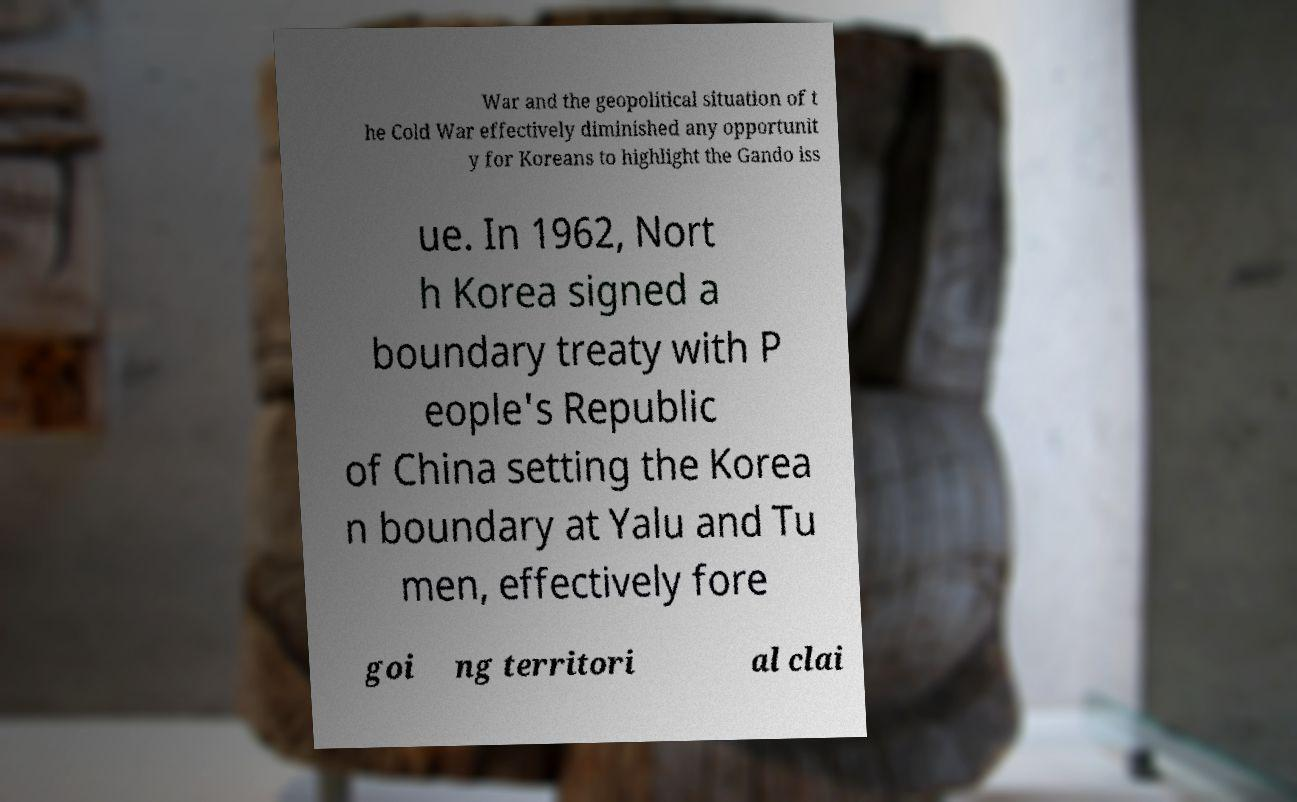There's text embedded in this image that I need extracted. Can you transcribe it verbatim? War and the geopolitical situation of t he Cold War effectively diminished any opportunit y for Koreans to highlight the Gando iss ue. In 1962, Nort h Korea signed a boundary treaty with P eople's Republic of China setting the Korea n boundary at Yalu and Tu men, effectively fore goi ng territori al clai 